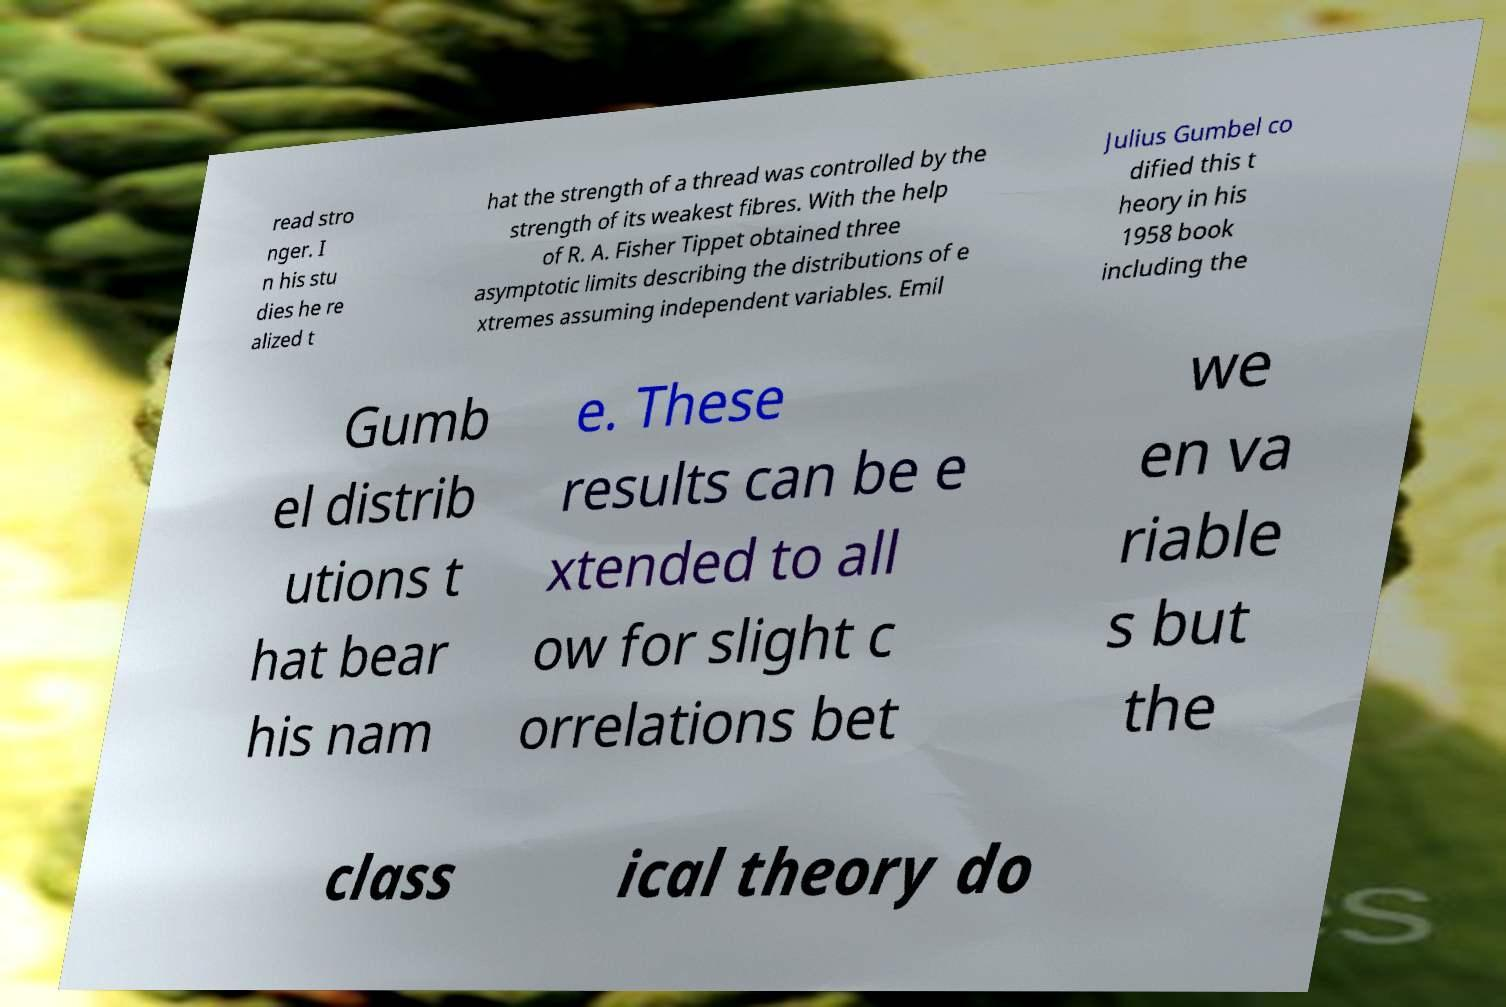What messages or text are displayed in this image? I need them in a readable, typed format. read stro nger. I n his stu dies he re alized t hat the strength of a thread was controlled by the strength of its weakest fibres. With the help of R. A. Fisher Tippet obtained three asymptotic limits describing the distributions of e xtremes assuming independent variables. Emil Julius Gumbel co dified this t heory in his 1958 book including the Gumb el distrib utions t hat bear his nam e. These results can be e xtended to all ow for slight c orrelations bet we en va riable s but the class ical theory do 